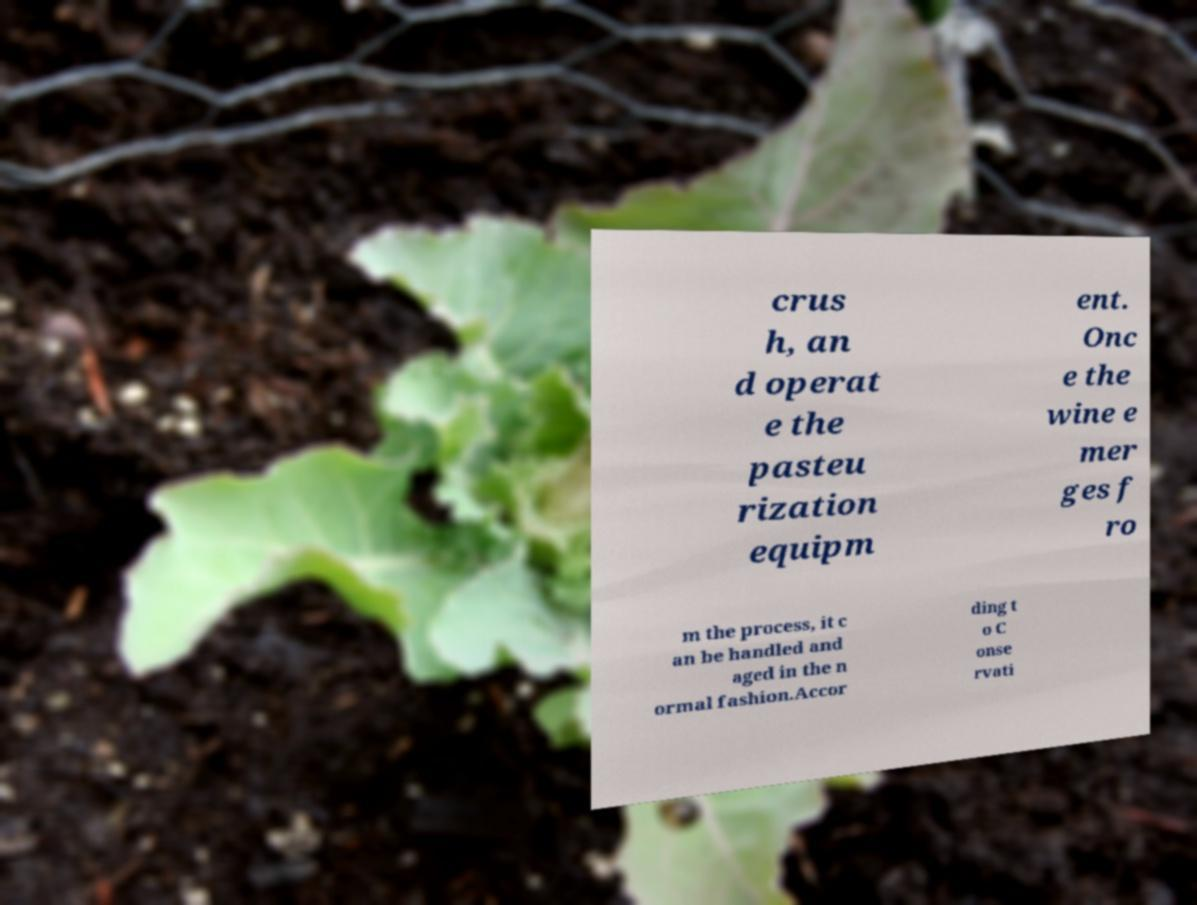Please read and relay the text visible in this image. What does it say? crus h, an d operat e the pasteu rization equipm ent. Onc e the wine e mer ges f ro m the process, it c an be handled and aged in the n ormal fashion.Accor ding t o C onse rvati 